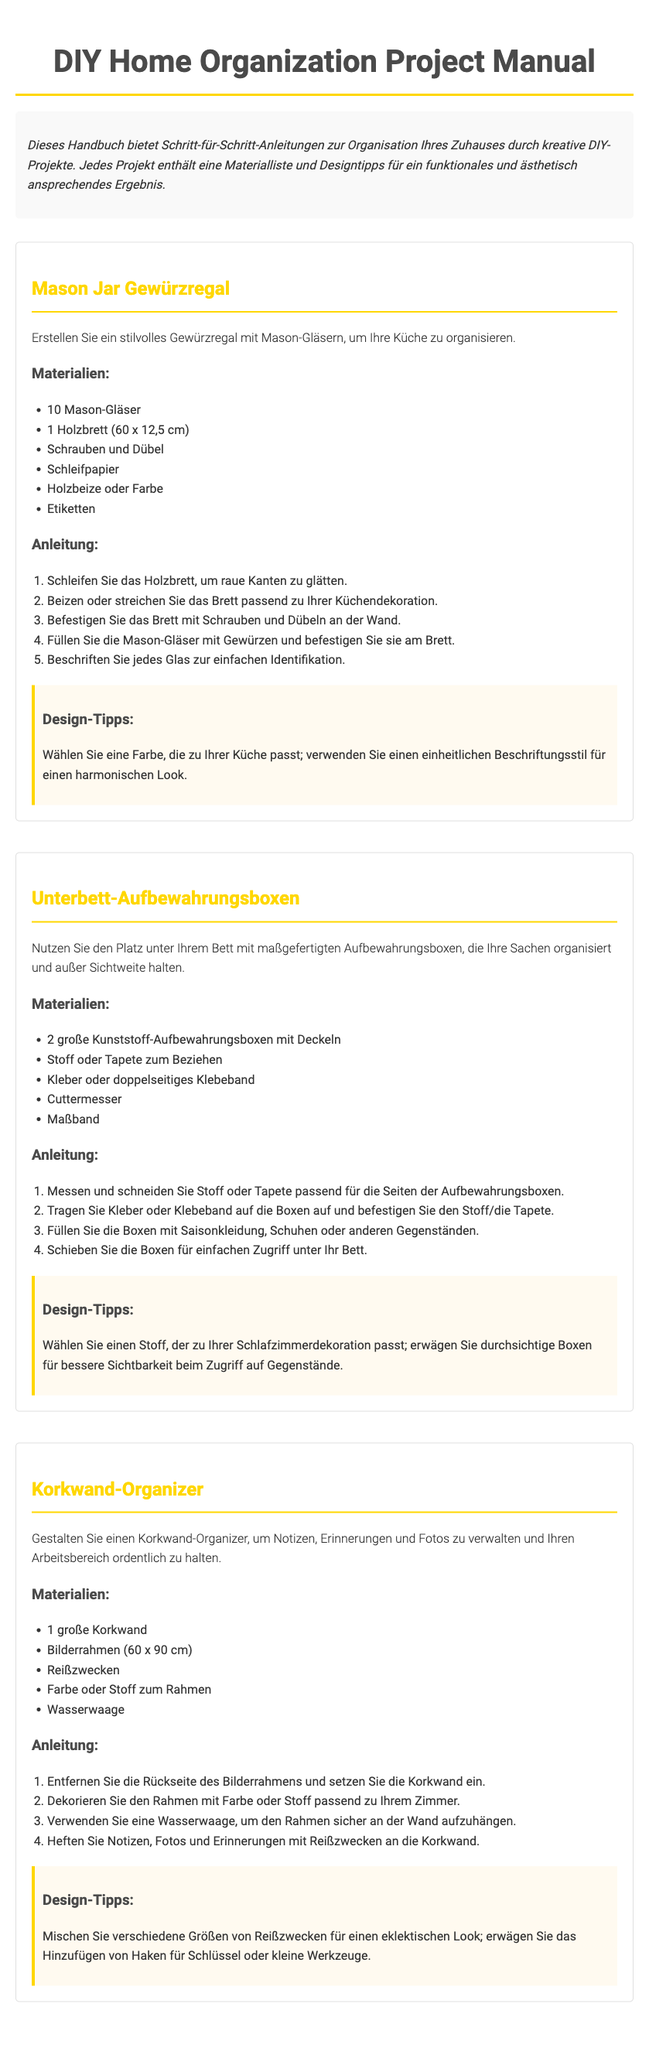Was ist der Titel des Handbuchs? Der Titel des Handbuchs ist die Hauptüberschrift, die den Inhalt zusammenfasst.
Answer: DIY Home Organization Project Manual Wie viele Mason-Gläser werden für das Gewürzregal benötigt? Die Anzahl der benötigten Mason-Gläser ist in der Materialliste für das Projekt aufgelistet.
Answer: 10 Mason-Gläser Was ist die Maße des Holzbretts für das Gewürzregal? Die Maße des Holzbretts sind in der Materialliste für das Gewürzregal angegeben.
Answer: 60 x 12,5 cm Welche Art von Aufbewahrungsboxen wird für das Unterbett-Projekt verwendet? Die Art der Aufbewahrungsboxen ist in der Materialliste für das Unterbett-Projekt angegeben.
Answer: Große Kunststoff-Aufbewahrungsboxen In welchem Raum wird der Korkwand-Organizer hauptsächlich verwendet? Der Hauptzweck des Korkwand-Organizers ist in der Projektbeschreibung erwähnt, die den Raum angibt, in dem er verwendet wird.
Answer: Arbeitsbereich Was sollte auf jedem Mason-Glas angebracht werden? Die Information, was auf den Mason-Gläsern platziert werden sollte, ist in den Anweisungen des Projekts enthalten.
Answer: Etiketten Was sind zwei Design-Tipps für das Gewürzregal? Die Design-Tipps für das Gewürzregal sind in dem Abschnitt „Design-Tipps“ für dieses Projekt aufgeführt.
Answer: Eine Farbe wählen, die zur Küche passt; ein einheitlicher Beschriftungsstil Wie viele Anleitungen gibt es für das Korkwand-Projekt? Die Anzahl der Schritte in der Anleitung für das Korkwand-Projekt ist in der entsprechenden Anweisungsliste aufgeführt.
Answer: 4 Schritte 